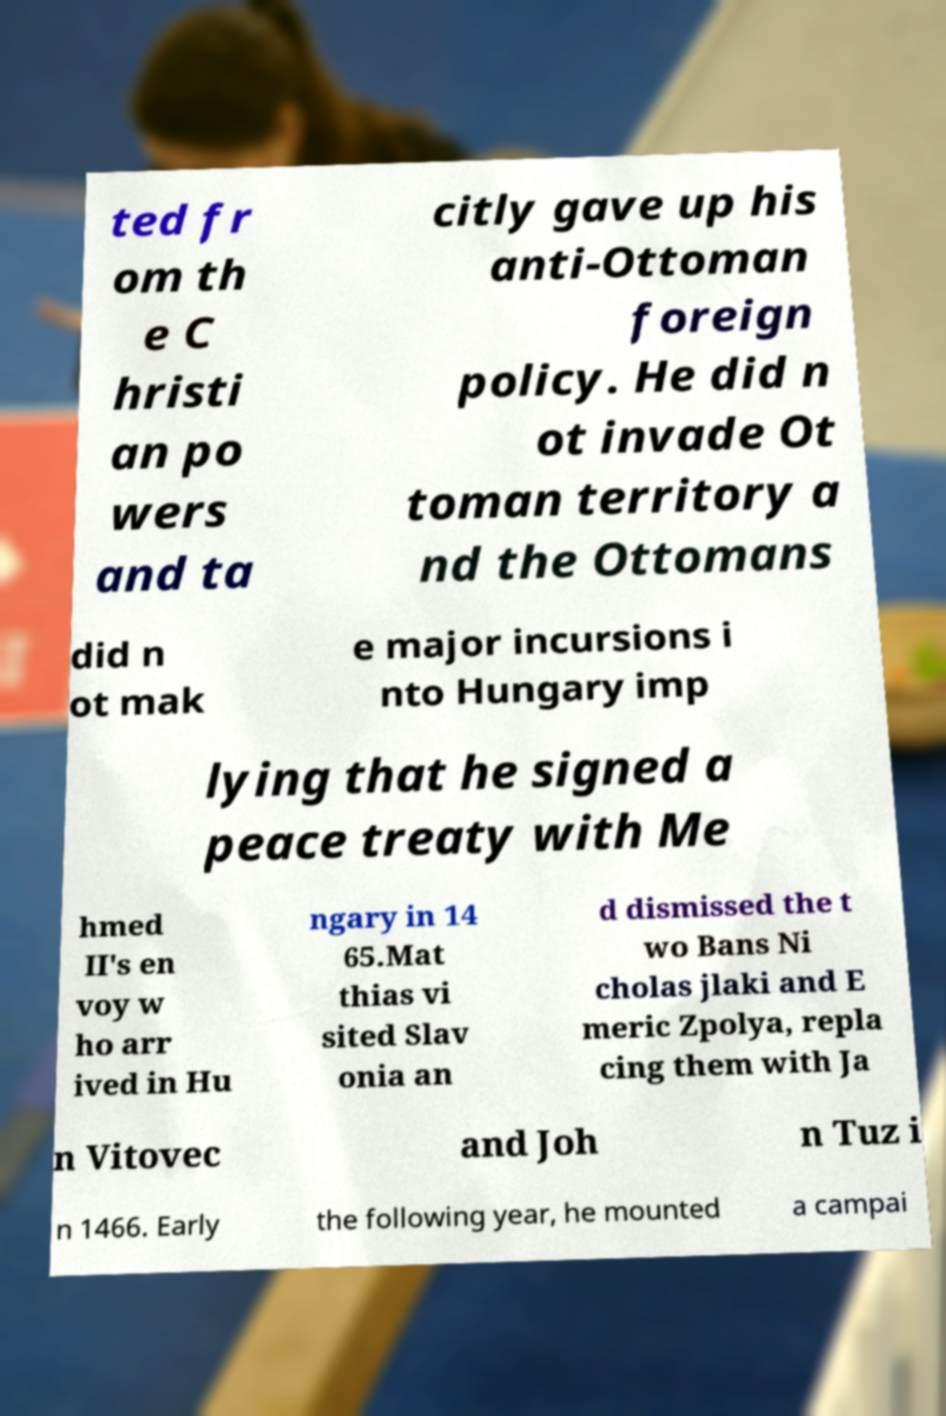Can you read and provide the text displayed in the image?This photo seems to have some interesting text. Can you extract and type it out for me? ted fr om th e C hristi an po wers and ta citly gave up his anti-Ottoman foreign policy. He did n ot invade Ot toman territory a nd the Ottomans did n ot mak e major incursions i nto Hungary imp lying that he signed a peace treaty with Me hmed II's en voy w ho arr ived in Hu ngary in 14 65.Mat thias vi sited Slav onia an d dismissed the t wo Bans Ni cholas jlaki and E meric Zpolya, repla cing them with Ja n Vitovec and Joh n Tuz i n 1466. Early the following year, he mounted a campai 